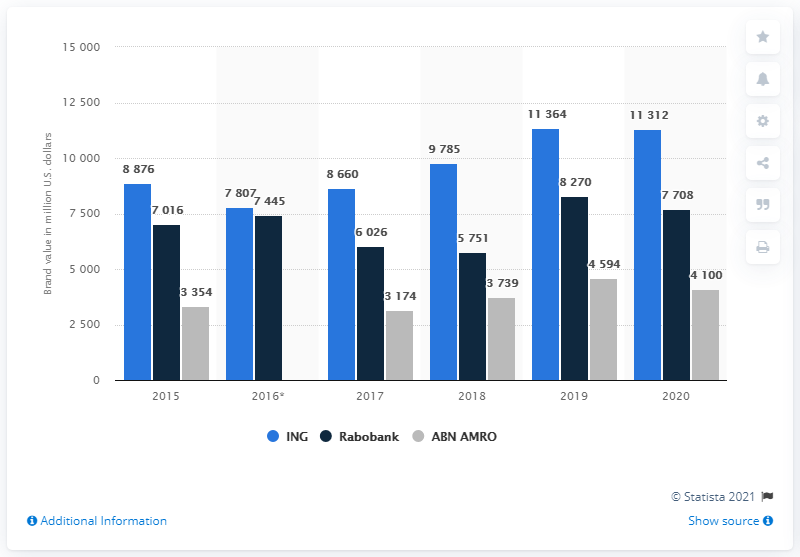Mention a couple of crucial points in this snapshot. Rabobank, a Dutch bank, has experienced a two-year decrease in growth between 2016 and 2018. The leftmost light bar has a value of 8876. According to an estimate in 2020, ING's brand value was estimated to be approximately 11,364 US dollars. The brand value of the Dutch banks ING, Rabobank, and ABN AMRO on 2015 was 64.15%. 